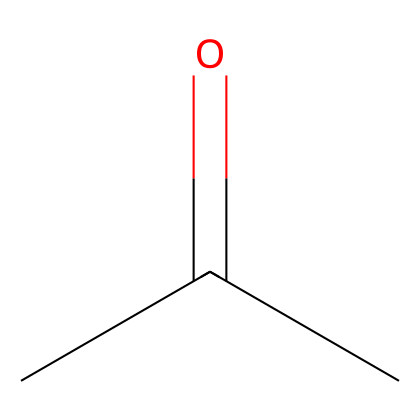How many carbon atoms are present in acetone? The SMILES representation CC(=O)C indicates that there are two carbon atoms represented as "C" and "C" in the sequence. Therefore, the total number of carbon atoms in acetone is 3, as one is double-bonded to an oxygen atom.
Answer: 3 What is the functional group of acetone? The presence of the carbonyl group represented by the "C(=O)" in the SMILES indicates that the functional group of acetone is a ketone.
Answer: ketone What type of solvent is acetone commonly classified as? Acetone is used as a solvent for various applications, and it is commonly classified as a polar aprotic solvent because it can dissolve a wide range of polar and nonpolar substances without having hydrogen bonding with solutes.
Answer: polar aprotic What is the degree of saturation of acetone? The structure contains a carbonyl group (C=O) and does not have any rings or multiple bonds besides the double bond with oxygen, so acetone has a degree of saturation of 1. This indicates that one double bond is present.
Answer: 1 How many hydrogen atoms are in acetone? In the molecular structure from the SMILES representation CC(=O)C, each carbon atom typically bonds to enough hydrogen atoms to satisfy its tetravalency. The center carbon, which is double-bonded to oxygen, bonds to only one hydrogen, while the other two carbon atoms bond to three hydrogen atoms each. Therefore, the total number of hydrogen atoms is 6.
Answer: 6 What makes acetone effective as a paint thinner? Acetone is effective as a paint thinner due to its ability to dissolve various chemical compounds, particularly resins and oils, which is facilitated by its polar aprotic nature and small molecular size, allowing for easy intercalation with paint components.
Answer: polar aprotic nature 